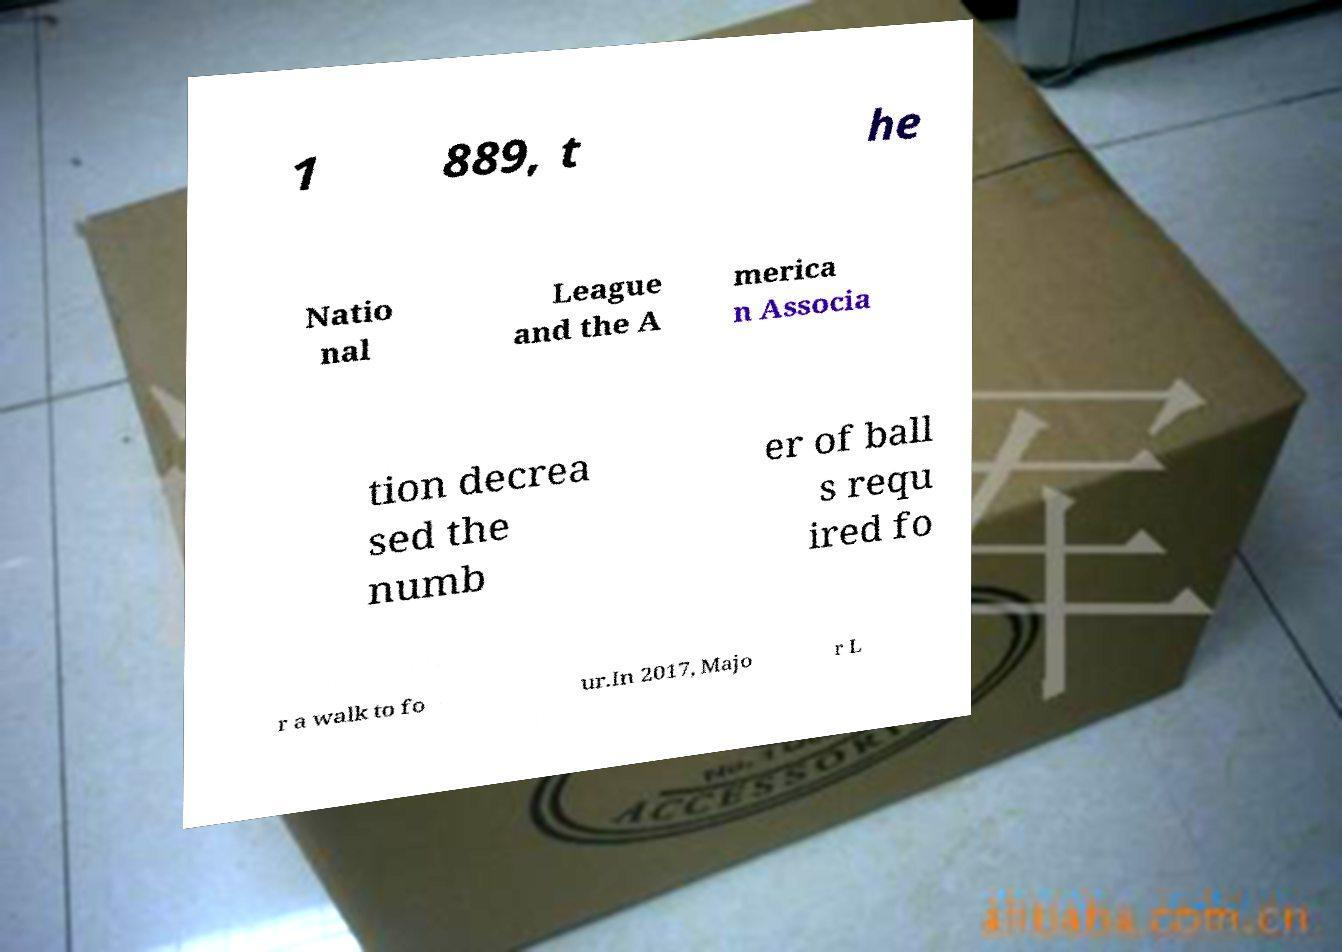Can you accurately transcribe the text from the provided image for me? 1 889, t he Natio nal League and the A merica n Associa tion decrea sed the numb er of ball s requ ired fo r a walk to fo ur.In 2017, Majo r L 